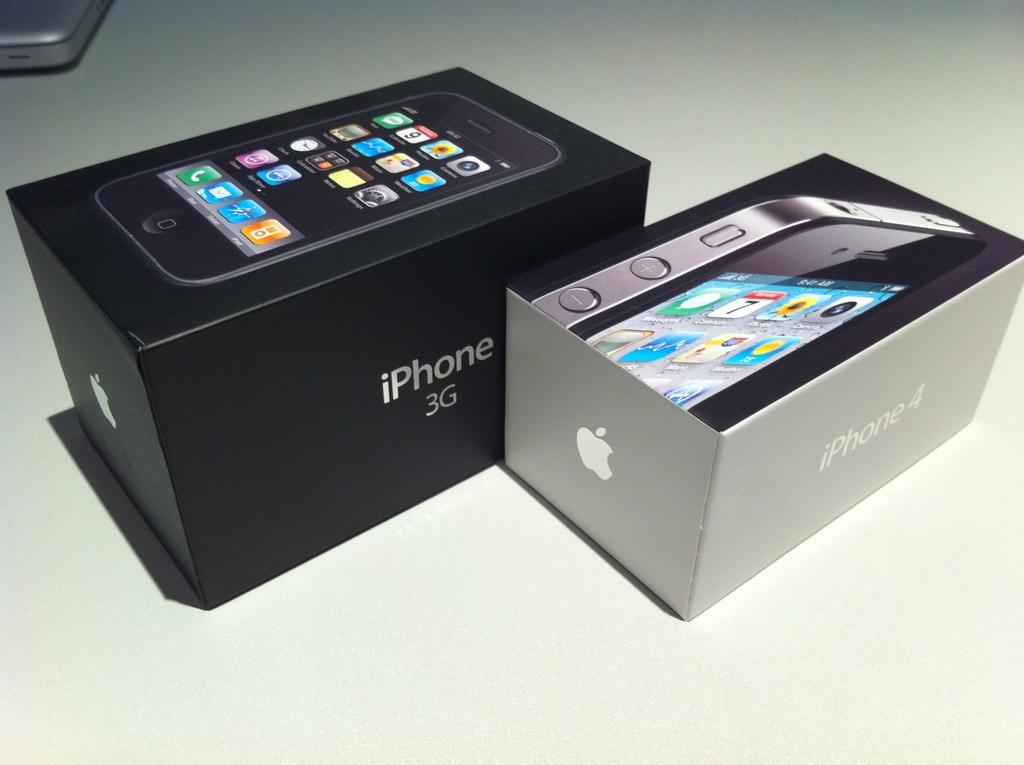<image>
Render a clear and concise summary of the photo. A box containing a new Apple iPhone 3G 